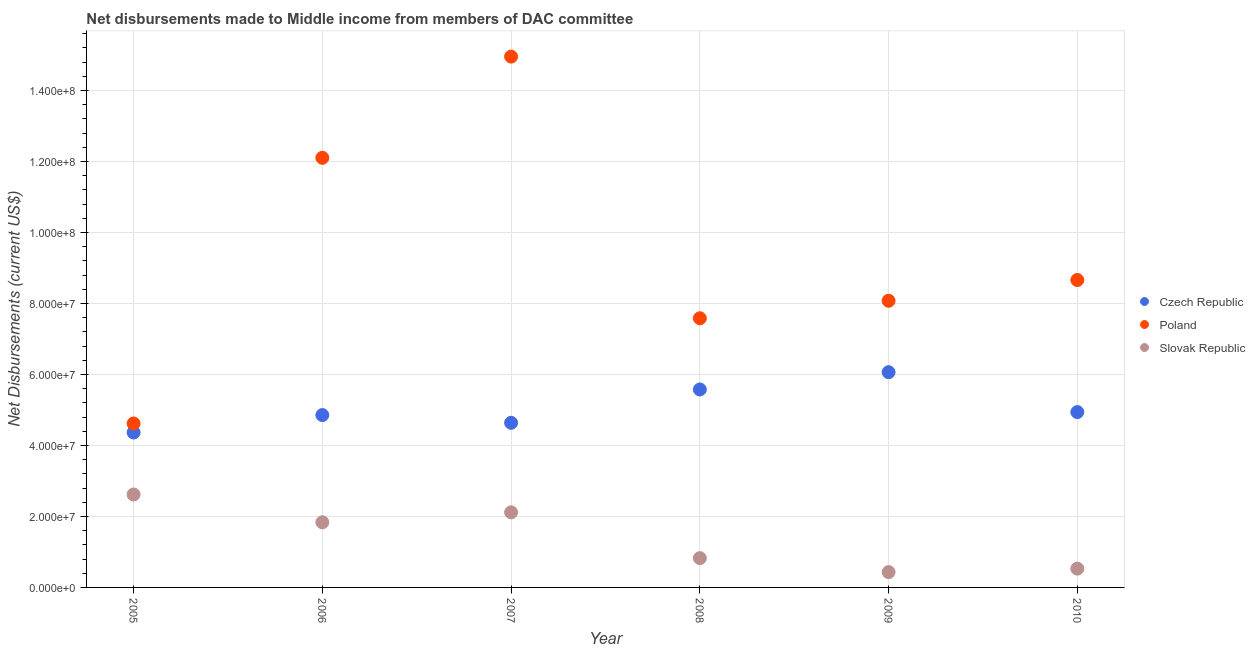How many different coloured dotlines are there?
Offer a terse response. 3. What is the net disbursements made by poland in 2009?
Your answer should be compact. 8.08e+07. Across all years, what is the maximum net disbursements made by poland?
Your answer should be very brief. 1.50e+08. Across all years, what is the minimum net disbursements made by czech republic?
Keep it short and to the point. 4.36e+07. What is the total net disbursements made by czech republic in the graph?
Keep it short and to the point. 3.04e+08. What is the difference between the net disbursements made by poland in 2008 and that in 2010?
Provide a succinct answer. -1.08e+07. What is the difference between the net disbursements made by slovak republic in 2007 and the net disbursements made by poland in 2005?
Your answer should be compact. -2.50e+07. What is the average net disbursements made by czech republic per year?
Make the answer very short. 5.07e+07. In the year 2005, what is the difference between the net disbursements made by slovak republic and net disbursements made by poland?
Offer a very short reply. -2.00e+07. What is the ratio of the net disbursements made by poland in 2006 to that in 2007?
Give a very brief answer. 0.81. Is the net disbursements made by czech republic in 2005 less than that in 2007?
Your response must be concise. Yes. Is the difference between the net disbursements made by poland in 2007 and 2009 greater than the difference between the net disbursements made by czech republic in 2007 and 2009?
Give a very brief answer. Yes. What is the difference between the highest and the second highest net disbursements made by czech republic?
Your response must be concise. 4.87e+06. What is the difference between the highest and the lowest net disbursements made by slovak republic?
Ensure brevity in your answer.  2.19e+07. Is the net disbursements made by czech republic strictly less than the net disbursements made by slovak republic over the years?
Offer a very short reply. No. How many years are there in the graph?
Ensure brevity in your answer.  6. Are the values on the major ticks of Y-axis written in scientific E-notation?
Provide a succinct answer. Yes. Does the graph contain grids?
Keep it short and to the point. Yes. How are the legend labels stacked?
Give a very brief answer. Vertical. What is the title of the graph?
Ensure brevity in your answer.  Net disbursements made to Middle income from members of DAC committee. Does "Ages 65 and above" appear as one of the legend labels in the graph?
Give a very brief answer. No. What is the label or title of the X-axis?
Ensure brevity in your answer.  Year. What is the label or title of the Y-axis?
Ensure brevity in your answer.  Net Disbursements (current US$). What is the Net Disbursements (current US$) of Czech Republic in 2005?
Provide a short and direct response. 4.36e+07. What is the Net Disbursements (current US$) of Poland in 2005?
Provide a short and direct response. 4.62e+07. What is the Net Disbursements (current US$) of Slovak Republic in 2005?
Your answer should be very brief. 2.62e+07. What is the Net Disbursements (current US$) of Czech Republic in 2006?
Give a very brief answer. 4.86e+07. What is the Net Disbursements (current US$) in Poland in 2006?
Your answer should be very brief. 1.21e+08. What is the Net Disbursements (current US$) in Slovak Republic in 2006?
Make the answer very short. 1.84e+07. What is the Net Disbursements (current US$) of Czech Republic in 2007?
Your answer should be very brief. 4.64e+07. What is the Net Disbursements (current US$) in Poland in 2007?
Keep it short and to the point. 1.50e+08. What is the Net Disbursements (current US$) in Slovak Republic in 2007?
Your response must be concise. 2.12e+07. What is the Net Disbursements (current US$) of Czech Republic in 2008?
Provide a succinct answer. 5.58e+07. What is the Net Disbursements (current US$) of Poland in 2008?
Keep it short and to the point. 7.58e+07. What is the Net Disbursements (current US$) of Slovak Republic in 2008?
Provide a short and direct response. 8.25e+06. What is the Net Disbursements (current US$) in Czech Republic in 2009?
Provide a short and direct response. 6.06e+07. What is the Net Disbursements (current US$) in Poland in 2009?
Offer a terse response. 8.08e+07. What is the Net Disbursements (current US$) in Slovak Republic in 2009?
Offer a very short reply. 4.32e+06. What is the Net Disbursements (current US$) of Czech Republic in 2010?
Keep it short and to the point. 4.94e+07. What is the Net Disbursements (current US$) in Poland in 2010?
Your response must be concise. 8.66e+07. What is the Net Disbursements (current US$) in Slovak Republic in 2010?
Your response must be concise. 5.29e+06. Across all years, what is the maximum Net Disbursements (current US$) of Czech Republic?
Give a very brief answer. 6.06e+07. Across all years, what is the maximum Net Disbursements (current US$) in Poland?
Give a very brief answer. 1.50e+08. Across all years, what is the maximum Net Disbursements (current US$) of Slovak Republic?
Make the answer very short. 2.62e+07. Across all years, what is the minimum Net Disbursements (current US$) of Czech Republic?
Ensure brevity in your answer.  4.36e+07. Across all years, what is the minimum Net Disbursements (current US$) in Poland?
Your answer should be very brief. 4.62e+07. Across all years, what is the minimum Net Disbursements (current US$) in Slovak Republic?
Your response must be concise. 4.32e+06. What is the total Net Disbursements (current US$) in Czech Republic in the graph?
Keep it short and to the point. 3.04e+08. What is the total Net Disbursements (current US$) in Poland in the graph?
Make the answer very short. 5.60e+08. What is the total Net Disbursements (current US$) of Slovak Republic in the graph?
Your response must be concise. 8.35e+07. What is the difference between the Net Disbursements (current US$) of Czech Republic in 2005 and that in 2006?
Your answer should be very brief. -4.92e+06. What is the difference between the Net Disbursements (current US$) in Poland in 2005 and that in 2006?
Keep it short and to the point. -7.48e+07. What is the difference between the Net Disbursements (current US$) in Slovak Republic in 2005 and that in 2006?
Keep it short and to the point. 7.83e+06. What is the difference between the Net Disbursements (current US$) in Czech Republic in 2005 and that in 2007?
Provide a short and direct response. -2.74e+06. What is the difference between the Net Disbursements (current US$) in Poland in 2005 and that in 2007?
Offer a terse response. -1.03e+08. What is the difference between the Net Disbursements (current US$) of Slovak Republic in 2005 and that in 2007?
Provide a succinct answer. 5.03e+06. What is the difference between the Net Disbursements (current US$) in Czech Republic in 2005 and that in 2008?
Your answer should be very brief. -1.21e+07. What is the difference between the Net Disbursements (current US$) of Poland in 2005 and that in 2008?
Offer a terse response. -2.96e+07. What is the difference between the Net Disbursements (current US$) of Slovak Republic in 2005 and that in 2008?
Your response must be concise. 1.79e+07. What is the difference between the Net Disbursements (current US$) of Czech Republic in 2005 and that in 2009?
Make the answer very short. -1.70e+07. What is the difference between the Net Disbursements (current US$) of Poland in 2005 and that in 2009?
Your response must be concise. -3.46e+07. What is the difference between the Net Disbursements (current US$) in Slovak Republic in 2005 and that in 2009?
Offer a very short reply. 2.19e+07. What is the difference between the Net Disbursements (current US$) of Czech Republic in 2005 and that in 2010?
Provide a short and direct response. -5.76e+06. What is the difference between the Net Disbursements (current US$) in Poland in 2005 and that in 2010?
Make the answer very short. -4.04e+07. What is the difference between the Net Disbursements (current US$) of Slovak Republic in 2005 and that in 2010?
Your answer should be very brief. 2.09e+07. What is the difference between the Net Disbursements (current US$) in Czech Republic in 2006 and that in 2007?
Offer a very short reply. 2.18e+06. What is the difference between the Net Disbursements (current US$) of Poland in 2006 and that in 2007?
Keep it short and to the point. -2.85e+07. What is the difference between the Net Disbursements (current US$) in Slovak Republic in 2006 and that in 2007?
Offer a very short reply. -2.80e+06. What is the difference between the Net Disbursements (current US$) in Czech Republic in 2006 and that in 2008?
Your answer should be compact. -7.21e+06. What is the difference between the Net Disbursements (current US$) in Poland in 2006 and that in 2008?
Offer a very short reply. 4.52e+07. What is the difference between the Net Disbursements (current US$) in Slovak Republic in 2006 and that in 2008?
Provide a succinct answer. 1.01e+07. What is the difference between the Net Disbursements (current US$) of Czech Republic in 2006 and that in 2009?
Your answer should be very brief. -1.21e+07. What is the difference between the Net Disbursements (current US$) of Poland in 2006 and that in 2009?
Your response must be concise. 4.03e+07. What is the difference between the Net Disbursements (current US$) of Slovak Republic in 2006 and that in 2009?
Offer a terse response. 1.40e+07. What is the difference between the Net Disbursements (current US$) of Czech Republic in 2006 and that in 2010?
Give a very brief answer. -8.40e+05. What is the difference between the Net Disbursements (current US$) in Poland in 2006 and that in 2010?
Offer a terse response. 3.44e+07. What is the difference between the Net Disbursements (current US$) of Slovak Republic in 2006 and that in 2010?
Your response must be concise. 1.31e+07. What is the difference between the Net Disbursements (current US$) in Czech Republic in 2007 and that in 2008?
Your answer should be very brief. -9.39e+06. What is the difference between the Net Disbursements (current US$) in Poland in 2007 and that in 2008?
Provide a succinct answer. 7.37e+07. What is the difference between the Net Disbursements (current US$) in Slovak Republic in 2007 and that in 2008?
Offer a very short reply. 1.29e+07. What is the difference between the Net Disbursements (current US$) of Czech Republic in 2007 and that in 2009?
Make the answer very short. -1.43e+07. What is the difference between the Net Disbursements (current US$) of Poland in 2007 and that in 2009?
Keep it short and to the point. 6.88e+07. What is the difference between the Net Disbursements (current US$) in Slovak Republic in 2007 and that in 2009?
Your response must be concise. 1.68e+07. What is the difference between the Net Disbursements (current US$) in Czech Republic in 2007 and that in 2010?
Give a very brief answer. -3.02e+06. What is the difference between the Net Disbursements (current US$) of Poland in 2007 and that in 2010?
Ensure brevity in your answer.  6.29e+07. What is the difference between the Net Disbursements (current US$) in Slovak Republic in 2007 and that in 2010?
Your answer should be compact. 1.59e+07. What is the difference between the Net Disbursements (current US$) in Czech Republic in 2008 and that in 2009?
Ensure brevity in your answer.  -4.87e+06. What is the difference between the Net Disbursements (current US$) in Poland in 2008 and that in 2009?
Provide a succinct answer. -4.93e+06. What is the difference between the Net Disbursements (current US$) of Slovak Republic in 2008 and that in 2009?
Make the answer very short. 3.93e+06. What is the difference between the Net Disbursements (current US$) in Czech Republic in 2008 and that in 2010?
Your answer should be compact. 6.37e+06. What is the difference between the Net Disbursements (current US$) of Poland in 2008 and that in 2010?
Your answer should be very brief. -1.08e+07. What is the difference between the Net Disbursements (current US$) of Slovak Republic in 2008 and that in 2010?
Your answer should be very brief. 2.96e+06. What is the difference between the Net Disbursements (current US$) in Czech Republic in 2009 and that in 2010?
Your answer should be compact. 1.12e+07. What is the difference between the Net Disbursements (current US$) in Poland in 2009 and that in 2010?
Make the answer very short. -5.85e+06. What is the difference between the Net Disbursements (current US$) in Slovak Republic in 2009 and that in 2010?
Keep it short and to the point. -9.70e+05. What is the difference between the Net Disbursements (current US$) of Czech Republic in 2005 and the Net Disbursements (current US$) of Poland in 2006?
Provide a short and direct response. -7.74e+07. What is the difference between the Net Disbursements (current US$) of Czech Republic in 2005 and the Net Disbursements (current US$) of Slovak Republic in 2006?
Keep it short and to the point. 2.53e+07. What is the difference between the Net Disbursements (current US$) in Poland in 2005 and the Net Disbursements (current US$) in Slovak Republic in 2006?
Ensure brevity in your answer.  2.78e+07. What is the difference between the Net Disbursements (current US$) of Czech Republic in 2005 and the Net Disbursements (current US$) of Poland in 2007?
Your answer should be very brief. -1.06e+08. What is the difference between the Net Disbursements (current US$) in Czech Republic in 2005 and the Net Disbursements (current US$) in Slovak Republic in 2007?
Provide a short and direct response. 2.25e+07. What is the difference between the Net Disbursements (current US$) of Poland in 2005 and the Net Disbursements (current US$) of Slovak Republic in 2007?
Give a very brief answer. 2.50e+07. What is the difference between the Net Disbursements (current US$) in Czech Republic in 2005 and the Net Disbursements (current US$) in Poland in 2008?
Provide a short and direct response. -3.22e+07. What is the difference between the Net Disbursements (current US$) of Czech Republic in 2005 and the Net Disbursements (current US$) of Slovak Republic in 2008?
Your answer should be very brief. 3.54e+07. What is the difference between the Net Disbursements (current US$) of Poland in 2005 and the Net Disbursements (current US$) of Slovak Republic in 2008?
Your response must be concise. 3.79e+07. What is the difference between the Net Disbursements (current US$) in Czech Republic in 2005 and the Net Disbursements (current US$) in Poland in 2009?
Make the answer very short. -3.71e+07. What is the difference between the Net Disbursements (current US$) of Czech Republic in 2005 and the Net Disbursements (current US$) of Slovak Republic in 2009?
Offer a very short reply. 3.93e+07. What is the difference between the Net Disbursements (current US$) in Poland in 2005 and the Net Disbursements (current US$) in Slovak Republic in 2009?
Provide a succinct answer. 4.19e+07. What is the difference between the Net Disbursements (current US$) of Czech Republic in 2005 and the Net Disbursements (current US$) of Poland in 2010?
Offer a terse response. -4.30e+07. What is the difference between the Net Disbursements (current US$) in Czech Republic in 2005 and the Net Disbursements (current US$) in Slovak Republic in 2010?
Offer a terse response. 3.84e+07. What is the difference between the Net Disbursements (current US$) of Poland in 2005 and the Net Disbursements (current US$) of Slovak Republic in 2010?
Your answer should be compact. 4.09e+07. What is the difference between the Net Disbursements (current US$) in Czech Republic in 2006 and the Net Disbursements (current US$) in Poland in 2007?
Your response must be concise. -1.01e+08. What is the difference between the Net Disbursements (current US$) of Czech Republic in 2006 and the Net Disbursements (current US$) of Slovak Republic in 2007?
Give a very brief answer. 2.74e+07. What is the difference between the Net Disbursements (current US$) in Poland in 2006 and the Net Disbursements (current US$) in Slovak Republic in 2007?
Your answer should be compact. 9.99e+07. What is the difference between the Net Disbursements (current US$) in Czech Republic in 2006 and the Net Disbursements (current US$) in Poland in 2008?
Give a very brief answer. -2.73e+07. What is the difference between the Net Disbursements (current US$) in Czech Republic in 2006 and the Net Disbursements (current US$) in Slovak Republic in 2008?
Give a very brief answer. 4.03e+07. What is the difference between the Net Disbursements (current US$) of Poland in 2006 and the Net Disbursements (current US$) of Slovak Republic in 2008?
Keep it short and to the point. 1.13e+08. What is the difference between the Net Disbursements (current US$) in Czech Republic in 2006 and the Net Disbursements (current US$) in Poland in 2009?
Your response must be concise. -3.22e+07. What is the difference between the Net Disbursements (current US$) in Czech Republic in 2006 and the Net Disbursements (current US$) in Slovak Republic in 2009?
Offer a very short reply. 4.42e+07. What is the difference between the Net Disbursements (current US$) of Poland in 2006 and the Net Disbursements (current US$) of Slovak Republic in 2009?
Provide a succinct answer. 1.17e+08. What is the difference between the Net Disbursements (current US$) of Czech Republic in 2006 and the Net Disbursements (current US$) of Poland in 2010?
Give a very brief answer. -3.80e+07. What is the difference between the Net Disbursements (current US$) of Czech Republic in 2006 and the Net Disbursements (current US$) of Slovak Republic in 2010?
Offer a very short reply. 4.33e+07. What is the difference between the Net Disbursements (current US$) of Poland in 2006 and the Net Disbursements (current US$) of Slovak Republic in 2010?
Your answer should be very brief. 1.16e+08. What is the difference between the Net Disbursements (current US$) in Czech Republic in 2007 and the Net Disbursements (current US$) in Poland in 2008?
Make the answer very short. -2.94e+07. What is the difference between the Net Disbursements (current US$) of Czech Republic in 2007 and the Net Disbursements (current US$) of Slovak Republic in 2008?
Offer a very short reply. 3.81e+07. What is the difference between the Net Disbursements (current US$) of Poland in 2007 and the Net Disbursements (current US$) of Slovak Republic in 2008?
Give a very brief answer. 1.41e+08. What is the difference between the Net Disbursements (current US$) in Czech Republic in 2007 and the Net Disbursements (current US$) in Poland in 2009?
Give a very brief answer. -3.44e+07. What is the difference between the Net Disbursements (current US$) in Czech Republic in 2007 and the Net Disbursements (current US$) in Slovak Republic in 2009?
Your response must be concise. 4.21e+07. What is the difference between the Net Disbursements (current US$) of Poland in 2007 and the Net Disbursements (current US$) of Slovak Republic in 2009?
Give a very brief answer. 1.45e+08. What is the difference between the Net Disbursements (current US$) in Czech Republic in 2007 and the Net Disbursements (current US$) in Poland in 2010?
Give a very brief answer. -4.02e+07. What is the difference between the Net Disbursements (current US$) of Czech Republic in 2007 and the Net Disbursements (current US$) of Slovak Republic in 2010?
Offer a terse response. 4.11e+07. What is the difference between the Net Disbursements (current US$) of Poland in 2007 and the Net Disbursements (current US$) of Slovak Republic in 2010?
Keep it short and to the point. 1.44e+08. What is the difference between the Net Disbursements (current US$) of Czech Republic in 2008 and the Net Disbursements (current US$) of Poland in 2009?
Offer a terse response. -2.50e+07. What is the difference between the Net Disbursements (current US$) of Czech Republic in 2008 and the Net Disbursements (current US$) of Slovak Republic in 2009?
Your answer should be very brief. 5.14e+07. What is the difference between the Net Disbursements (current US$) of Poland in 2008 and the Net Disbursements (current US$) of Slovak Republic in 2009?
Give a very brief answer. 7.15e+07. What is the difference between the Net Disbursements (current US$) of Czech Republic in 2008 and the Net Disbursements (current US$) of Poland in 2010?
Keep it short and to the point. -3.08e+07. What is the difference between the Net Disbursements (current US$) in Czech Republic in 2008 and the Net Disbursements (current US$) in Slovak Republic in 2010?
Provide a short and direct response. 5.05e+07. What is the difference between the Net Disbursements (current US$) of Poland in 2008 and the Net Disbursements (current US$) of Slovak Republic in 2010?
Provide a short and direct response. 7.05e+07. What is the difference between the Net Disbursements (current US$) in Czech Republic in 2009 and the Net Disbursements (current US$) in Poland in 2010?
Your answer should be compact. -2.60e+07. What is the difference between the Net Disbursements (current US$) in Czech Republic in 2009 and the Net Disbursements (current US$) in Slovak Republic in 2010?
Your response must be concise. 5.54e+07. What is the difference between the Net Disbursements (current US$) of Poland in 2009 and the Net Disbursements (current US$) of Slovak Republic in 2010?
Offer a very short reply. 7.55e+07. What is the average Net Disbursements (current US$) in Czech Republic per year?
Your response must be concise. 5.07e+07. What is the average Net Disbursements (current US$) in Poland per year?
Your answer should be very brief. 9.33e+07. What is the average Net Disbursements (current US$) in Slovak Republic per year?
Your answer should be very brief. 1.39e+07. In the year 2005, what is the difference between the Net Disbursements (current US$) of Czech Republic and Net Disbursements (current US$) of Poland?
Offer a very short reply. -2.55e+06. In the year 2005, what is the difference between the Net Disbursements (current US$) of Czech Republic and Net Disbursements (current US$) of Slovak Republic?
Offer a very short reply. 1.75e+07. In the year 2005, what is the difference between the Net Disbursements (current US$) in Poland and Net Disbursements (current US$) in Slovak Republic?
Keep it short and to the point. 2.00e+07. In the year 2006, what is the difference between the Net Disbursements (current US$) of Czech Republic and Net Disbursements (current US$) of Poland?
Offer a terse response. -7.25e+07. In the year 2006, what is the difference between the Net Disbursements (current US$) of Czech Republic and Net Disbursements (current US$) of Slovak Republic?
Keep it short and to the point. 3.02e+07. In the year 2006, what is the difference between the Net Disbursements (current US$) in Poland and Net Disbursements (current US$) in Slovak Republic?
Provide a succinct answer. 1.03e+08. In the year 2007, what is the difference between the Net Disbursements (current US$) of Czech Republic and Net Disbursements (current US$) of Poland?
Your answer should be compact. -1.03e+08. In the year 2007, what is the difference between the Net Disbursements (current US$) of Czech Republic and Net Disbursements (current US$) of Slovak Republic?
Keep it short and to the point. 2.52e+07. In the year 2007, what is the difference between the Net Disbursements (current US$) of Poland and Net Disbursements (current US$) of Slovak Republic?
Provide a short and direct response. 1.28e+08. In the year 2008, what is the difference between the Net Disbursements (current US$) of Czech Republic and Net Disbursements (current US$) of Poland?
Make the answer very short. -2.01e+07. In the year 2008, what is the difference between the Net Disbursements (current US$) of Czech Republic and Net Disbursements (current US$) of Slovak Republic?
Your answer should be very brief. 4.75e+07. In the year 2008, what is the difference between the Net Disbursements (current US$) in Poland and Net Disbursements (current US$) in Slovak Republic?
Offer a very short reply. 6.76e+07. In the year 2009, what is the difference between the Net Disbursements (current US$) of Czech Republic and Net Disbursements (current US$) of Poland?
Provide a short and direct response. -2.01e+07. In the year 2009, what is the difference between the Net Disbursements (current US$) of Czech Republic and Net Disbursements (current US$) of Slovak Republic?
Your answer should be very brief. 5.63e+07. In the year 2009, what is the difference between the Net Disbursements (current US$) of Poland and Net Disbursements (current US$) of Slovak Republic?
Keep it short and to the point. 7.64e+07. In the year 2010, what is the difference between the Net Disbursements (current US$) of Czech Republic and Net Disbursements (current US$) of Poland?
Offer a terse response. -3.72e+07. In the year 2010, what is the difference between the Net Disbursements (current US$) in Czech Republic and Net Disbursements (current US$) in Slovak Republic?
Offer a very short reply. 4.41e+07. In the year 2010, what is the difference between the Net Disbursements (current US$) in Poland and Net Disbursements (current US$) in Slovak Republic?
Give a very brief answer. 8.13e+07. What is the ratio of the Net Disbursements (current US$) in Czech Republic in 2005 to that in 2006?
Give a very brief answer. 0.9. What is the ratio of the Net Disbursements (current US$) of Poland in 2005 to that in 2006?
Ensure brevity in your answer.  0.38. What is the ratio of the Net Disbursements (current US$) in Slovak Republic in 2005 to that in 2006?
Give a very brief answer. 1.43. What is the ratio of the Net Disbursements (current US$) of Czech Republic in 2005 to that in 2007?
Your answer should be compact. 0.94. What is the ratio of the Net Disbursements (current US$) in Poland in 2005 to that in 2007?
Offer a terse response. 0.31. What is the ratio of the Net Disbursements (current US$) of Slovak Republic in 2005 to that in 2007?
Provide a succinct answer. 1.24. What is the ratio of the Net Disbursements (current US$) of Czech Republic in 2005 to that in 2008?
Your answer should be compact. 0.78. What is the ratio of the Net Disbursements (current US$) of Poland in 2005 to that in 2008?
Provide a short and direct response. 0.61. What is the ratio of the Net Disbursements (current US$) of Slovak Republic in 2005 to that in 2008?
Offer a terse response. 3.17. What is the ratio of the Net Disbursements (current US$) of Czech Republic in 2005 to that in 2009?
Your answer should be very brief. 0.72. What is the ratio of the Net Disbursements (current US$) in Poland in 2005 to that in 2009?
Your response must be concise. 0.57. What is the ratio of the Net Disbursements (current US$) of Slovak Republic in 2005 to that in 2009?
Your answer should be very brief. 6.06. What is the ratio of the Net Disbursements (current US$) in Czech Republic in 2005 to that in 2010?
Offer a terse response. 0.88. What is the ratio of the Net Disbursements (current US$) of Poland in 2005 to that in 2010?
Ensure brevity in your answer.  0.53. What is the ratio of the Net Disbursements (current US$) in Slovak Republic in 2005 to that in 2010?
Provide a succinct answer. 4.95. What is the ratio of the Net Disbursements (current US$) of Czech Republic in 2006 to that in 2007?
Provide a short and direct response. 1.05. What is the ratio of the Net Disbursements (current US$) of Poland in 2006 to that in 2007?
Keep it short and to the point. 0.81. What is the ratio of the Net Disbursements (current US$) in Slovak Republic in 2006 to that in 2007?
Offer a terse response. 0.87. What is the ratio of the Net Disbursements (current US$) of Czech Republic in 2006 to that in 2008?
Your answer should be very brief. 0.87. What is the ratio of the Net Disbursements (current US$) of Poland in 2006 to that in 2008?
Offer a very short reply. 1.6. What is the ratio of the Net Disbursements (current US$) in Slovak Republic in 2006 to that in 2008?
Offer a terse response. 2.22. What is the ratio of the Net Disbursements (current US$) in Czech Republic in 2006 to that in 2009?
Give a very brief answer. 0.8. What is the ratio of the Net Disbursements (current US$) in Poland in 2006 to that in 2009?
Give a very brief answer. 1.5. What is the ratio of the Net Disbursements (current US$) in Slovak Republic in 2006 to that in 2009?
Provide a succinct answer. 4.25. What is the ratio of the Net Disbursements (current US$) in Poland in 2006 to that in 2010?
Your answer should be compact. 1.4. What is the ratio of the Net Disbursements (current US$) of Slovak Republic in 2006 to that in 2010?
Ensure brevity in your answer.  3.47. What is the ratio of the Net Disbursements (current US$) in Czech Republic in 2007 to that in 2008?
Offer a terse response. 0.83. What is the ratio of the Net Disbursements (current US$) in Poland in 2007 to that in 2008?
Your response must be concise. 1.97. What is the ratio of the Net Disbursements (current US$) in Slovak Republic in 2007 to that in 2008?
Ensure brevity in your answer.  2.56. What is the ratio of the Net Disbursements (current US$) in Czech Republic in 2007 to that in 2009?
Your answer should be very brief. 0.76. What is the ratio of the Net Disbursements (current US$) in Poland in 2007 to that in 2009?
Offer a terse response. 1.85. What is the ratio of the Net Disbursements (current US$) in Slovak Republic in 2007 to that in 2009?
Offer a terse response. 4.9. What is the ratio of the Net Disbursements (current US$) of Czech Republic in 2007 to that in 2010?
Offer a terse response. 0.94. What is the ratio of the Net Disbursements (current US$) in Poland in 2007 to that in 2010?
Offer a very short reply. 1.73. What is the ratio of the Net Disbursements (current US$) of Slovak Republic in 2007 to that in 2010?
Your response must be concise. 4. What is the ratio of the Net Disbursements (current US$) of Czech Republic in 2008 to that in 2009?
Your response must be concise. 0.92. What is the ratio of the Net Disbursements (current US$) of Poland in 2008 to that in 2009?
Your answer should be compact. 0.94. What is the ratio of the Net Disbursements (current US$) in Slovak Republic in 2008 to that in 2009?
Make the answer very short. 1.91. What is the ratio of the Net Disbursements (current US$) in Czech Republic in 2008 to that in 2010?
Ensure brevity in your answer.  1.13. What is the ratio of the Net Disbursements (current US$) in Poland in 2008 to that in 2010?
Give a very brief answer. 0.88. What is the ratio of the Net Disbursements (current US$) in Slovak Republic in 2008 to that in 2010?
Provide a short and direct response. 1.56. What is the ratio of the Net Disbursements (current US$) of Czech Republic in 2009 to that in 2010?
Your answer should be very brief. 1.23. What is the ratio of the Net Disbursements (current US$) in Poland in 2009 to that in 2010?
Provide a succinct answer. 0.93. What is the ratio of the Net Disbursements (current US$) in Slovak Republic in 2009 to that in 2010?
Your answer should be compact. 0.82. What is the difference between the highest and the second highest Net Disbursements (current US$) in Czech Republic?
Your answer should be very brief. 4.87e+06. What is the difference between the highest and the second highest Net Disbursements (current US$) of Poland?
Provide a short and direct response. 2.85e+07. What is the difference between the highest and the second highest Net Disbursements (current US$) in Slovak Republic?
Offer a terse response. 5.03e+06. What is the difference between the highest and the lowest Net Disbursements (current US$) in Czech Republic?
Provide a succinct answer. 1.70e+07. What is the difference between the highest and the lowest Net Disbursements (current US$) of Poland?
Give a very brief answer. 1.03e+08. What is the difference between the highest and the lowest Net Disbursements (current US$) of Slovak Republic?
Offer a very short reply. 2.19e+07. 